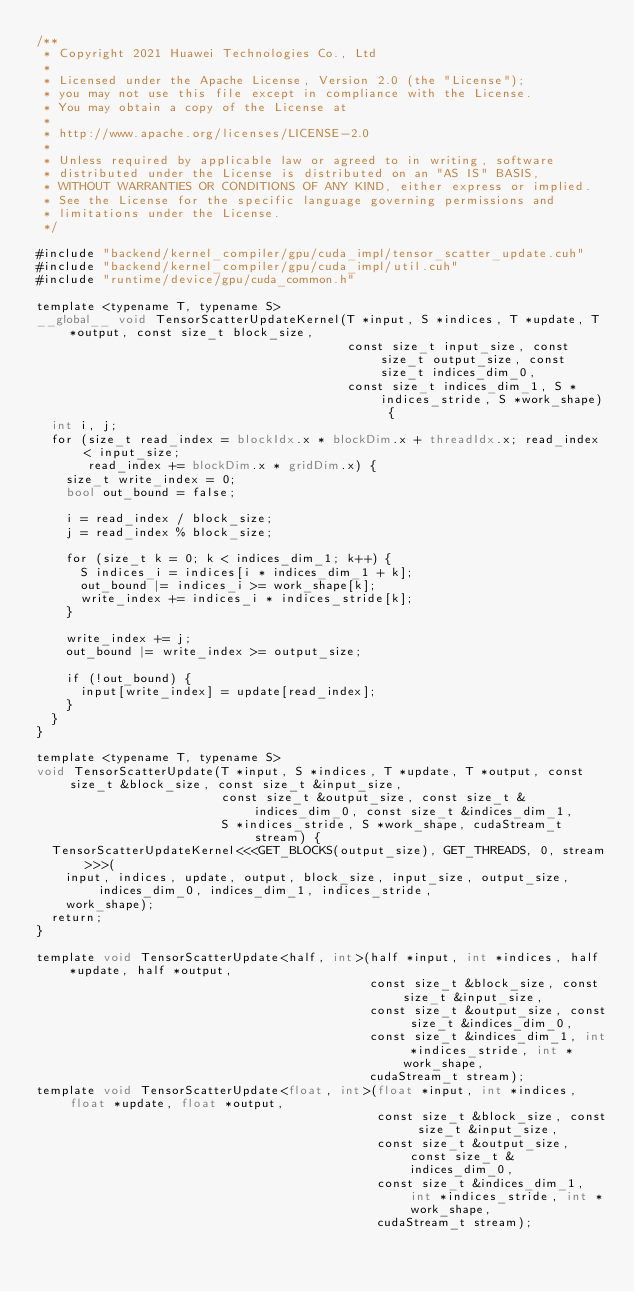<code> <loc_0><loc_0><loc_500><loc_500><_Cuda_>/**
 * Copyright 2021 Huawei Technologies Co., Ltd
 *
 * Licensed under the Apache License, Version 2.0 (the "License");
 * you may not use this file except in compliance with the License.
 * You may obtain a copy of the License at
 *
 * http://www.apache.org/licenses/LICENSE-2.0
 *
 * Unless required by applicable law or agreed to in writing, software
 * distributed under the License is distributed on an "AS IS" BASIS,
 * WITHOUT WARRANTIES OR CONDITIONS OF ANY KIND, either express or implied.
 * See the License for the specific language governing permissions and
 * limitations under the License.
 */

#include "backend/kernel_compiler/gpu/cuda_impl/tensor_scatter_update.cuh"
#include "backend/kernel_compiler/gpu/cuda_impl/util.cuh"
#include "runtime/device/gpu/cuda_common.h"

template <typename T, typename S>
__global__ void TensorScatterUpdateKernel(T *input, S *indices, T *update, T *output, const size_t block_size,
                                          const size_t input_size, const size_t output_size, const size_t indices_dim_0,
                                          const size_t indices_dim_1, S *indices_stride, S *work_shape) {
  int i, j;
  for (size_t read_index = blockIdx.x * blockDim.x + threadIdx.x; read_index < input_size;
       read_index += blockDim.x * gridDim.x) {
    size_t write_index = 0;
    bool out_bound = false;

    i = read_index / block_size;
    j = read_index % block_size;

    for (size_t k = 0; k < indices_dim_1; k++) {
      S indices_i = indices[i * indices_dim_1 + k];
      out_bound |= indices_i >= work_shape[k];
      write_index += indices_i * indices_stride[k];
    }

    write_index += j;
    out_bound |= write_index >= output_size;

    if (!out_bound) {
      input[write_index] = update[read_index];
    }
  }
}

template <typename T, typename S>
void TensorScatterUpdate(T *input, S *indices, T *update, T *output, const size_t &block_size, const size_t &input_size,
                         const size_t &output_size, const size_t &indices_dim_0, const size_t &indices_dim_1,
                         S *indices_stride, S *work_shape, cudaStream_t stream) {
  TensorScatterUpdateKernel<<<GET_BLOCKS(output_size), GET_THREADS, 0, stream>>>(
    input, indices, update, output, block_size, input_size, output_size, indices_dim_0, indices_dim_1, indices_stride,
    work_shape);
  return;
}

template void TensorScatterUpdate<half, int>(half *input, int *indices, half *update, half *output,
                                             const size_t &block_size, const size_t &input_size,
                                             const size_t &output_size, const size_t &indices_dim_0,
                                             const size_t &indices_dim_1, int *indices_stride, int *work_shape,
                                             cudaStream_t stream);
template void TensorScatterUpdate<float, int>(float *input, int *indices, float *update, float *output,
                                              const size_t &block_size, const size_t &input_size,
                                              const size_t &output_size, const size_t &indices_dim_0,
                                              const size_t &indices_dim_1, int *indices_stride, int *work_shape,
                                              cudaStream_t stream);</code> 